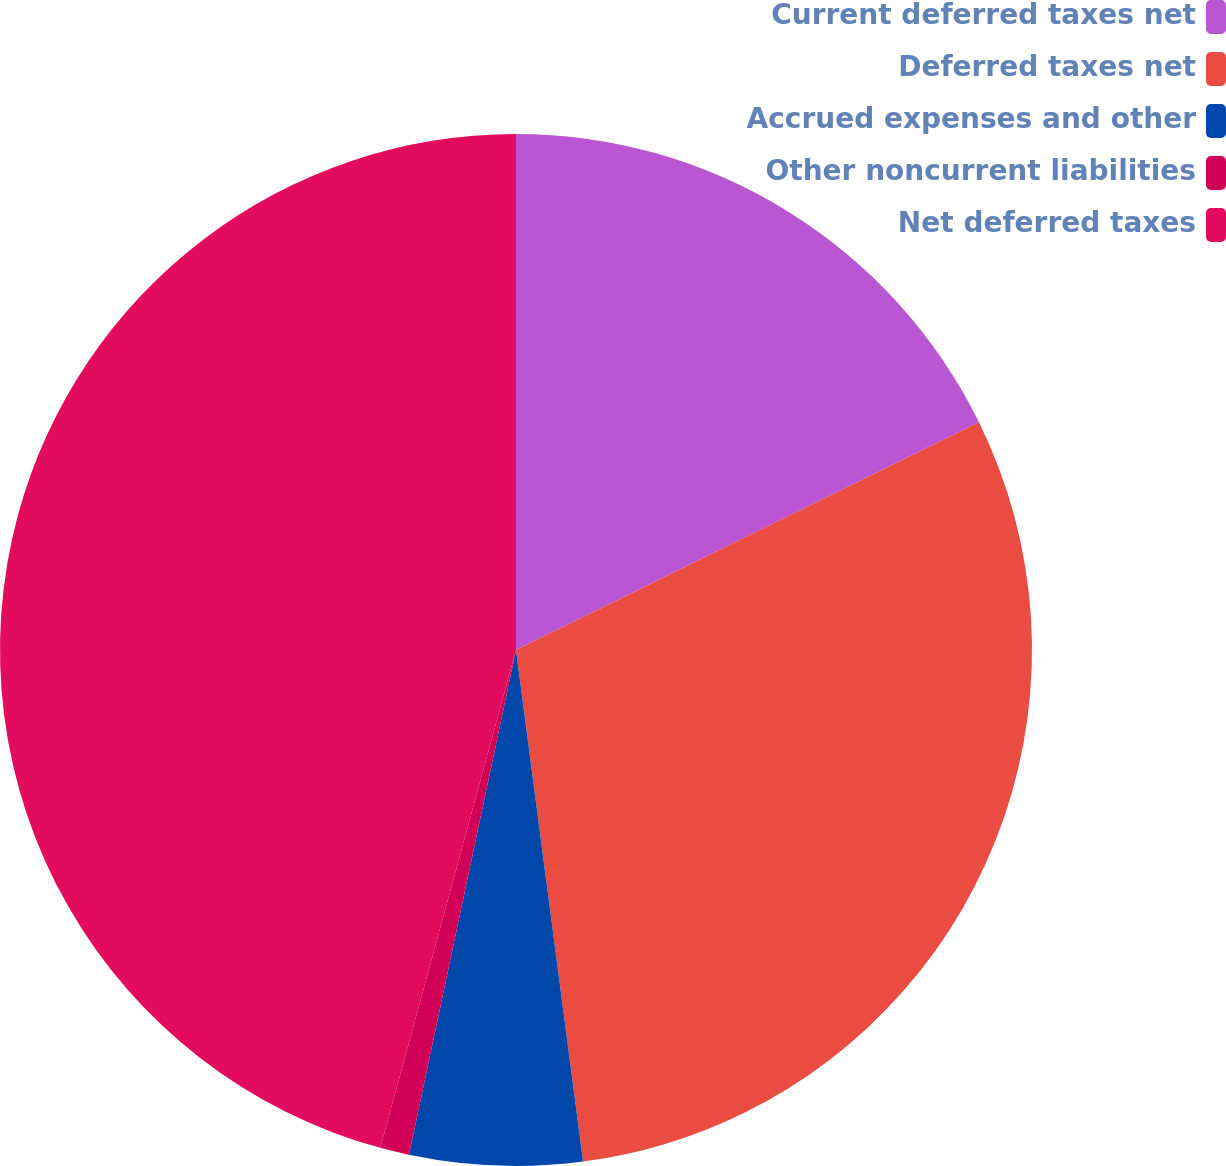Convert chart. <chart><loc_0><loc_0><loc_500><loc_500><pie_chart><fcel>Current deferred taxes net<fcel>Deferred taxes net<fcel>Accrued expenses and other<fcel>Other noncurrent liabilities<fcel>Net deferred taxes<nl><fcel>17.72%<fcel>30.2%<fcel>5.4%<fcel>0.91%<fcel>45.76%<nl></chart> 